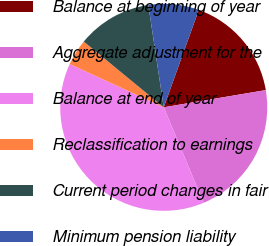Convert chart to OTSL. <chart><loc_0><loc_0><loc_500><loc_500><pie_chart><fcel>Balance at beginning of year<fcel>Aggregate adjustment for the<fcel>Balance at end of year<fcel>Reclassification to earnings<fcel>Current period changes in fair<fcel>Minimum pension liability<nl><fcel>16.84%<fcel>21.35%<fcel>38.18%<fcel>4.09%<fcel>11.67%<fcel>7.88%<nl></chart> 